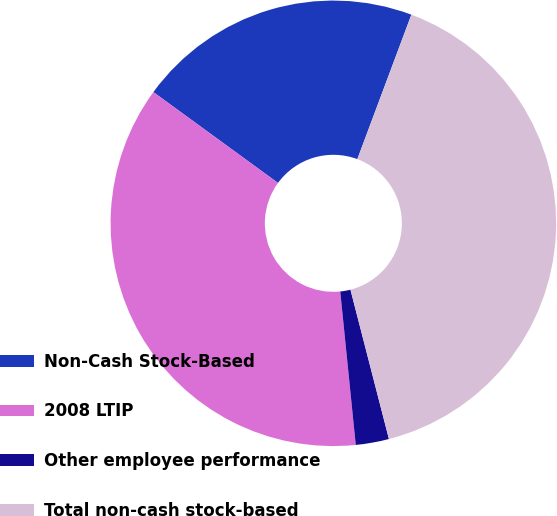Convert chart. <chart><loc_0><loc_0><loc_500><loc_500><pie_chart><fcel>Non-Cash Stock-Based<fcel>2008 LTIP<fcel>Other employee performance<fcel>Total non-cash stock-based<nl><fcel>20.67%<fcel>36.63%<fcel>2.41%<fcel>40.29%<nl></chart> 